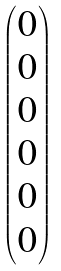<formula> <loc_0><loc_0><loc_500><loc_500>\begin{pmatrix} 0 \\ 0 \\ 0 \\ 0 \\ 0 \\ 0 \end{pmatrix}</formula> 